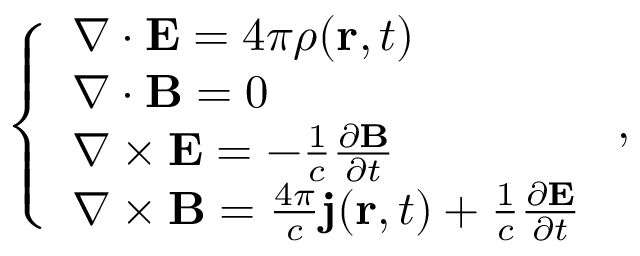Convert formula to latex. <formula><loc_0><loc_0><loc_500><loc_500>\left \{ \begin{array} { l l } { \nabla \cdot E = 4 \pi \rho ( r , t ) } \\ { \nabla \cdot B = 0 } \\ { \nabla \times E = - \frac { 1 } { c } \frac { \partial B } { \partial t } } \\ { \nabla \times B = \frac { 4 \pi } { c } j ( r , t ) + \frac { 1 } { c } \frac { \partial E } { \partial t } } \end{array} ,</formula> 